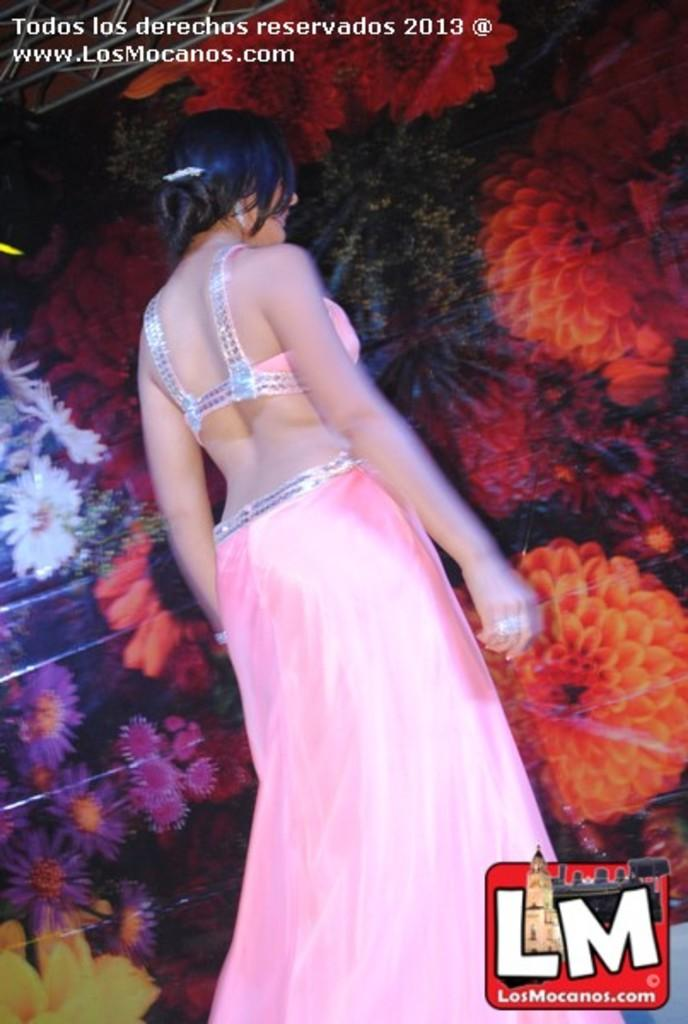Who is present in the image? There is a woman in the image. What can be seen at the top of the image? There is text at the top of the image. What type of shoe is the woman wearing in the image? There is no information about the woman's shoes in the image, so we cannot determine what type of shoe she is wearing. 